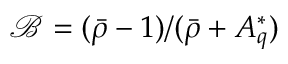<formula> <loc_0><loc_0><loc_500><loc_500>\mathcal { B } = ( \bar { \rho } - 1 ) / ( \bar { \rho } + A _ { q } ^ { * } )</formula> 